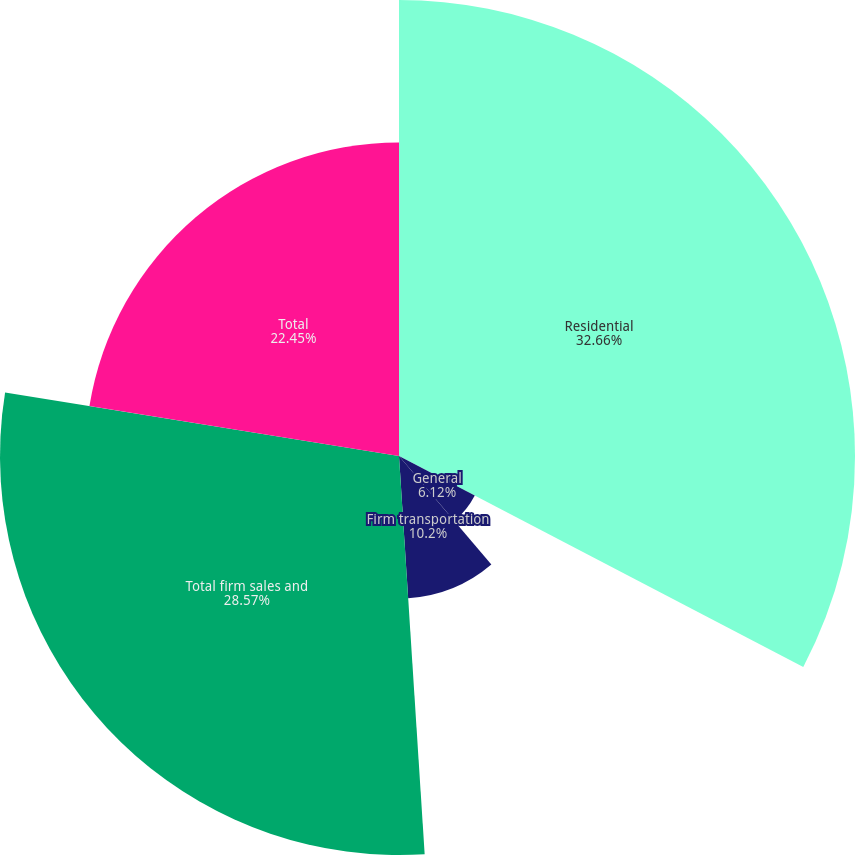Convert chart. <chart><loc_0><loc_0><loc_500><loc_500><pie_chart><fcel>Residential<fcel>General<fcel>Firm transportation<fcel>Total firm sales and<fcel>Total<nl><fcel>32.65%<fcel>6.12%<fcel>10.2%<fcel>28.57%<fcel>22.45%<nl></chart> 